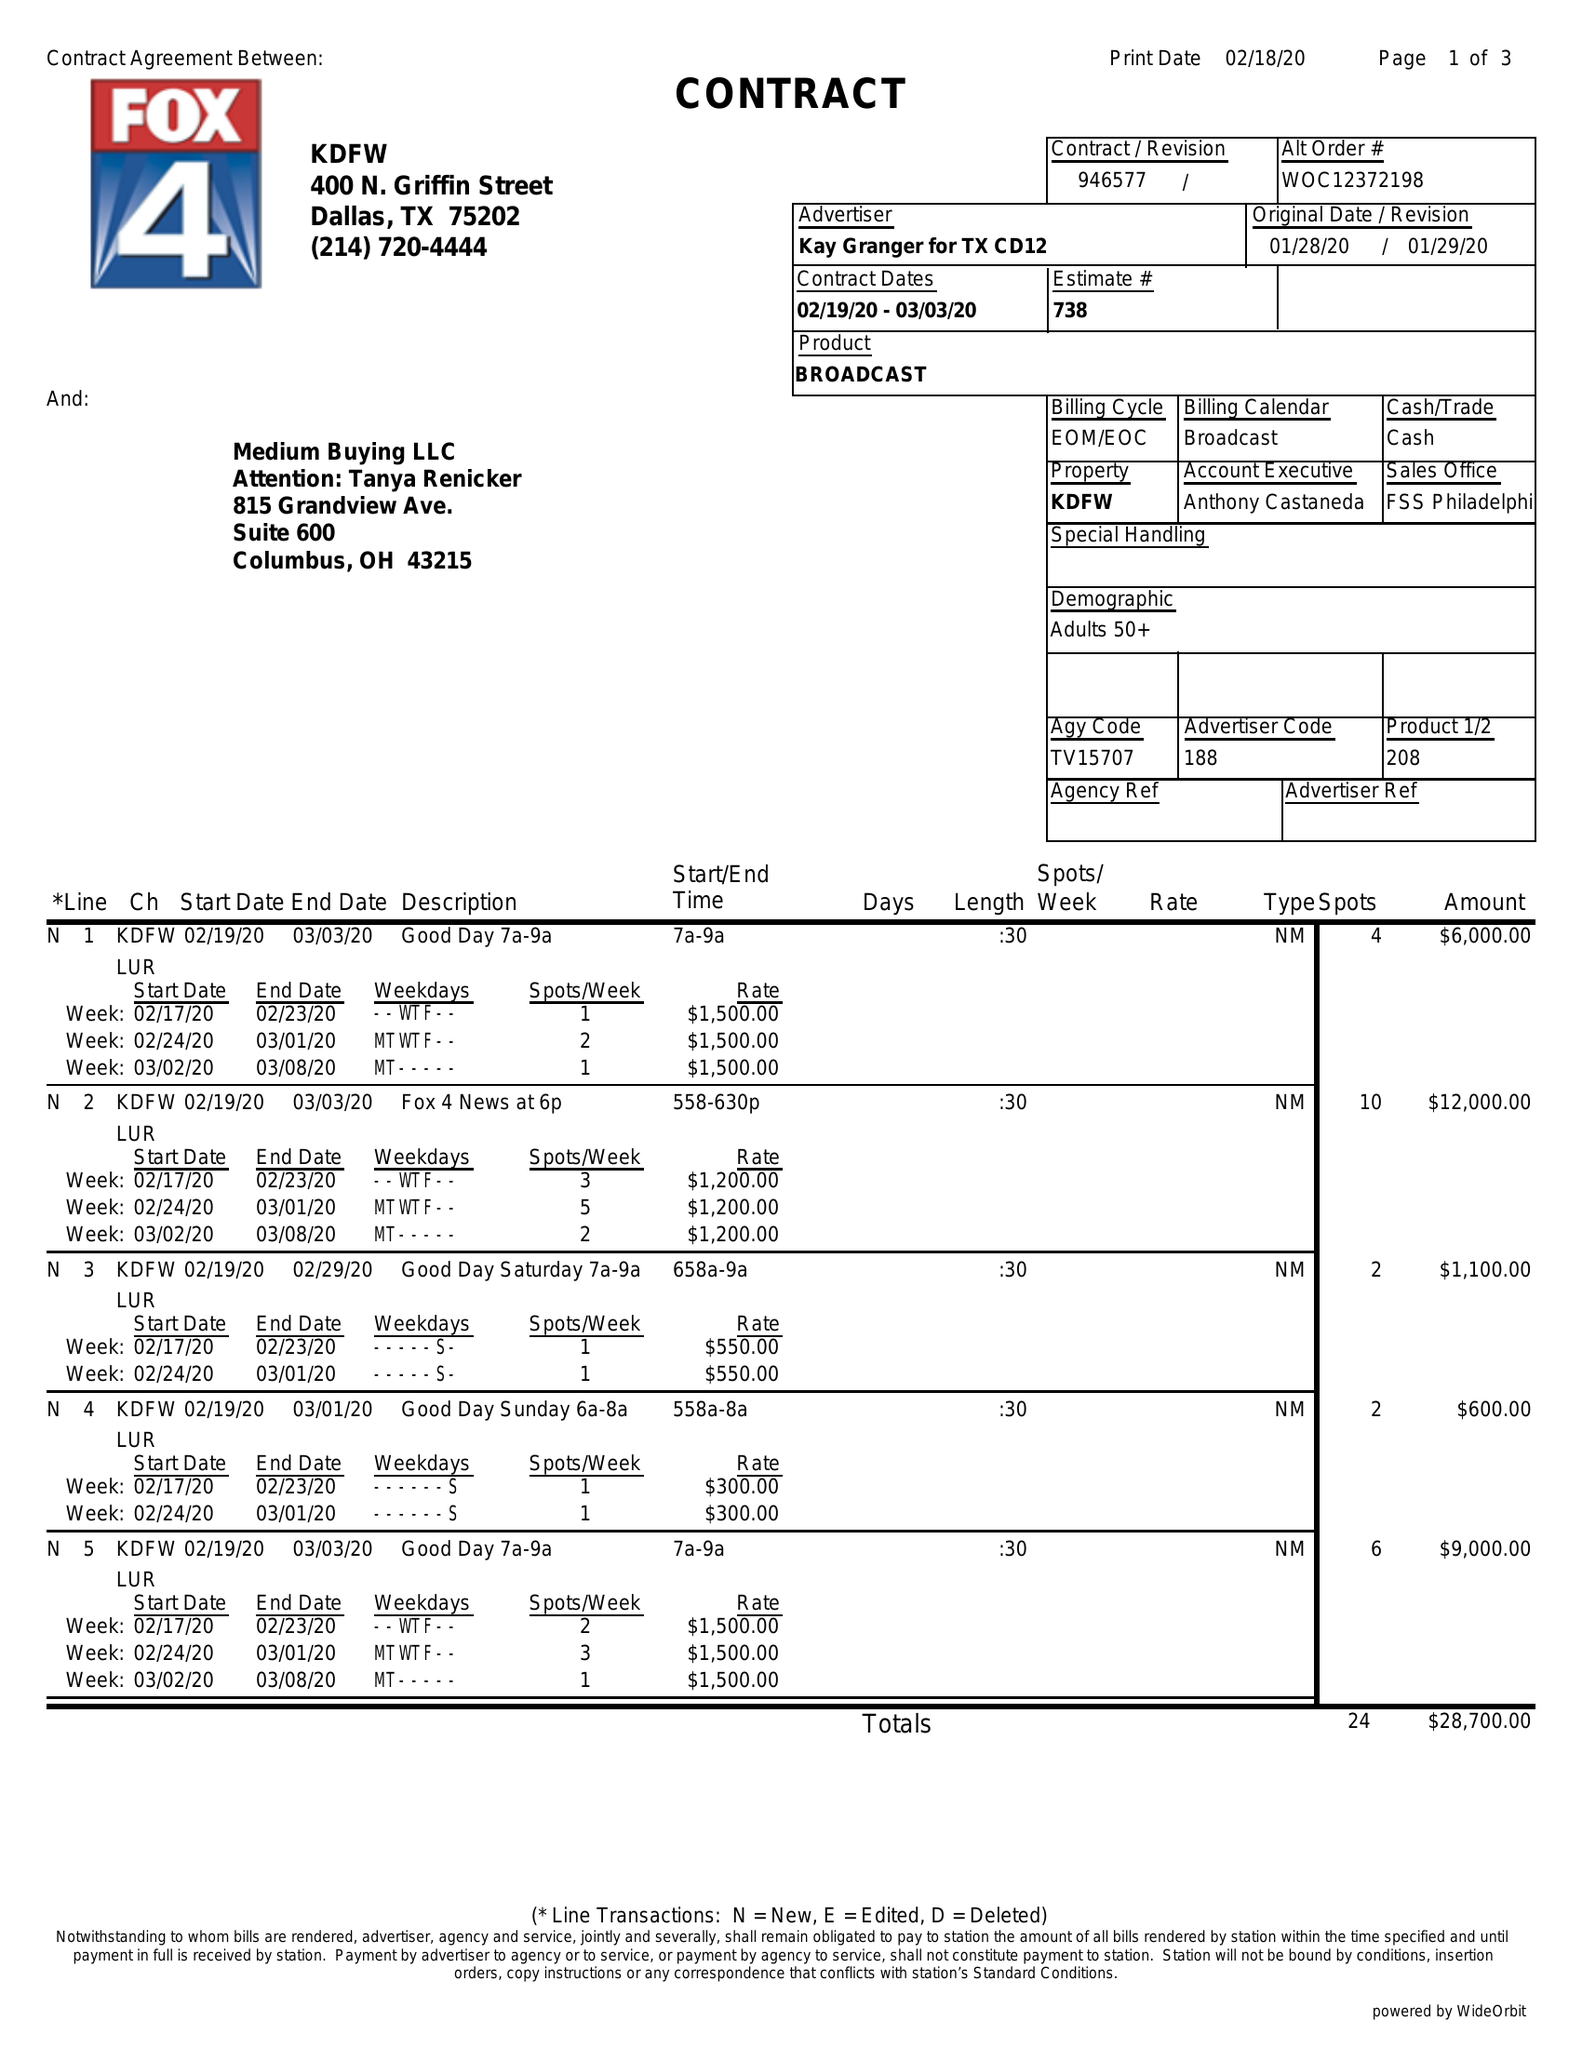What is the value for the flight_from?
Answer the question using a single word or phrase. 02/19/20 